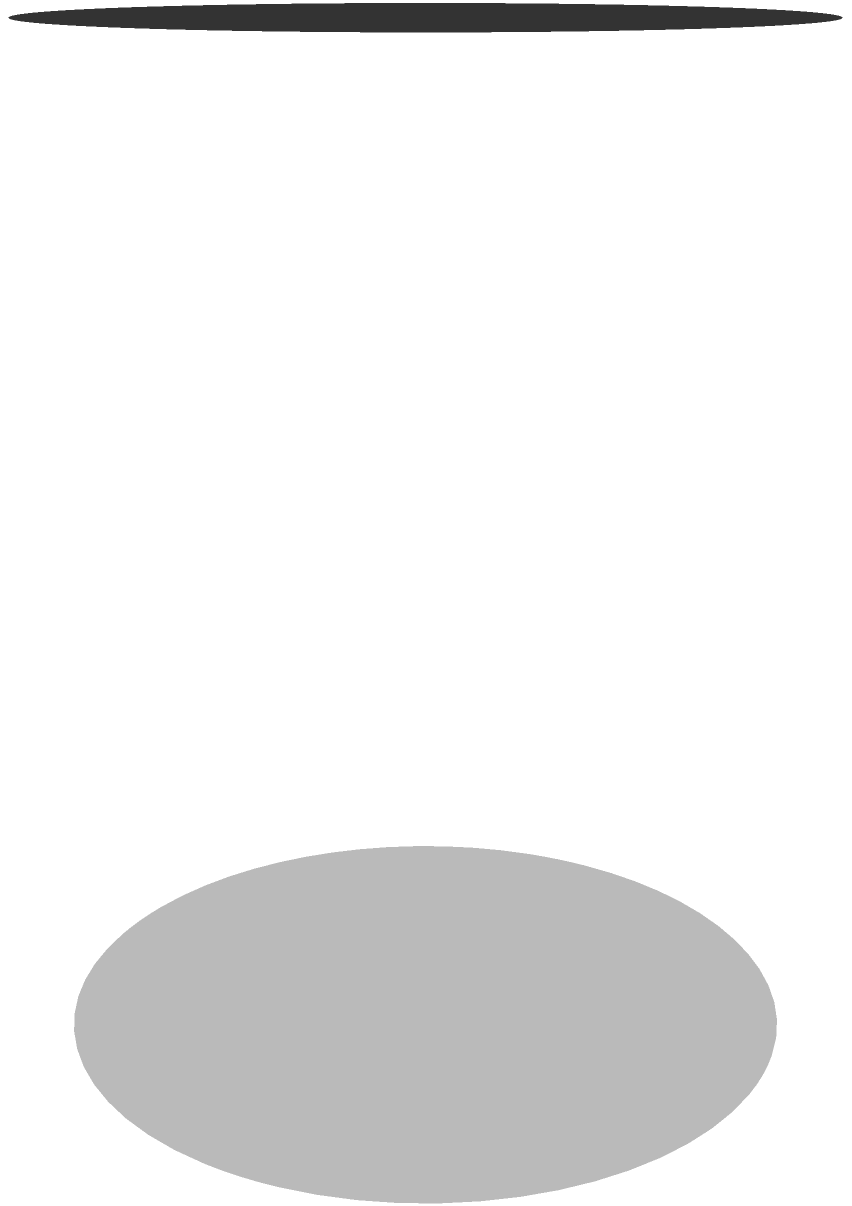During the Australian Open, you notice a cylindrical container filled with tennis balls. The container has a radius of 3.5 inches and a height of 10 inches. What is the volume of this container in cubic inches? To calculate the volume of a cylinder, we use the formula:

$$ V = \pi r^2 h $$

Where:
$V$ = volume
$r$ = radius
$h$ = height

Given:
$r = 3.5$ inches
$h = 10$ inches

Let's solve step by step:

1) Substitute the values into the formula:
   $$ V = \pi (3.5)^2 (10) $$

2) Calculate $r^2$:
   $$ V = \pi (12.25) (10) $$

3) Multiply the values inside the parentheses:
   $$ V = \pi (122.5) $$

4) Multiply by $\pi$ (use $\pi \approx 3.14159$ for precision):
   $$ V \approx 3.14159 \times 122.5 $$
   $$ V \approx 384.85 \text{ cubic inches} $$

5) Round to the nearest whole number:
   $$ V \approx 385 \text{ cubic inches} $$
Answer: 385 cubic inches 